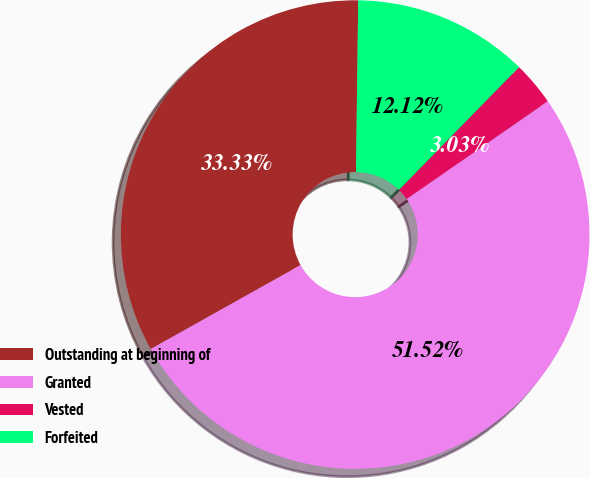Convert chart to OTSL. <chart><loc_0><loc_0><loc_500><loc_500><pie_chart><fcel>Outstanding at beginning of<fcel>Granted<fcel>Vested<fcel>Forfeited<nl><fcel>33.33%<fcel>51.52%<fcel>3.03%<fcel>12.12%<nl></chart> 